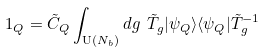<formula> <loc_0><loc_0><loc_500><loc_500>\ 1 _ { Q } = \tilde { C } _ { Q } \int _ { { \mathrm U } ( N _ { b } ) } d g \ \tilde { T } _ { g } | \psi _ { Q } \rangle \langle \psi _ { Q } | \tilde { T } _ { g } ^ { - 1 }</formula> 